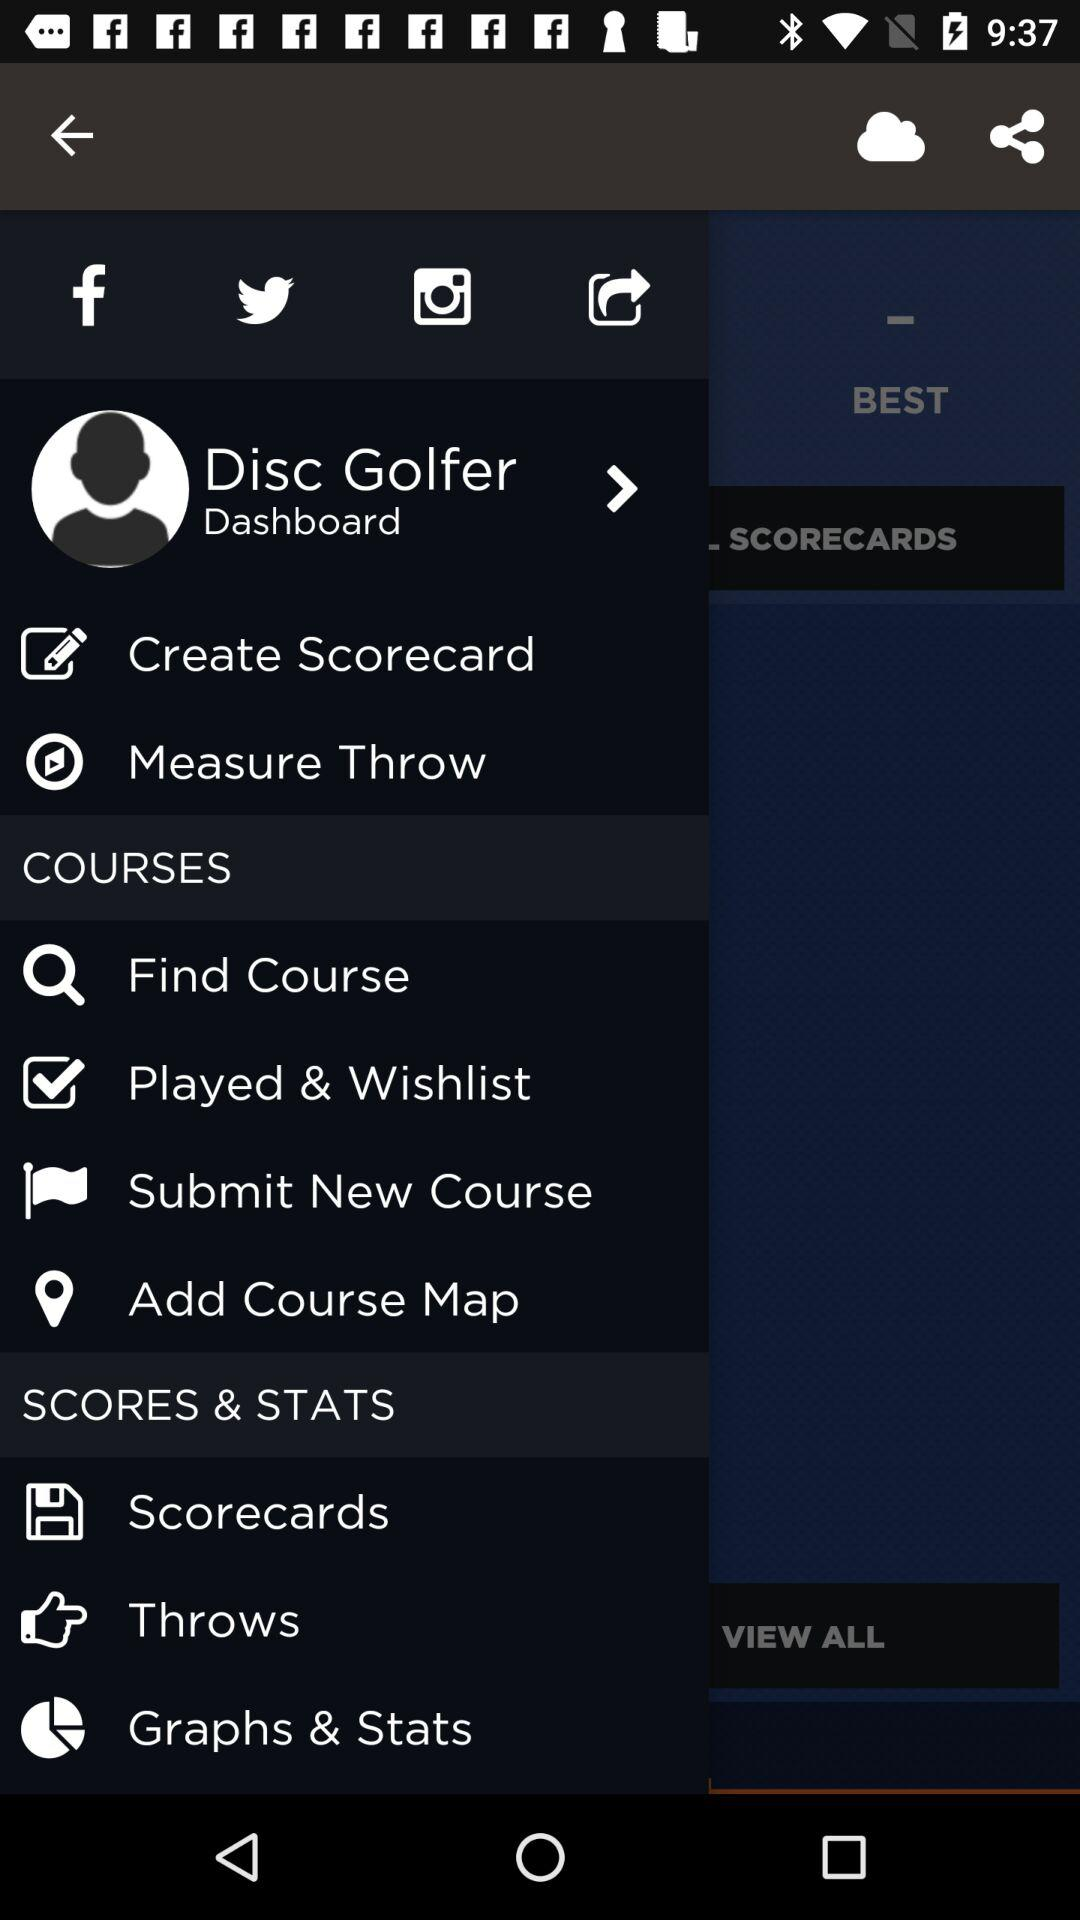What is the name of the user? The name of the user is Disc Golfer. 